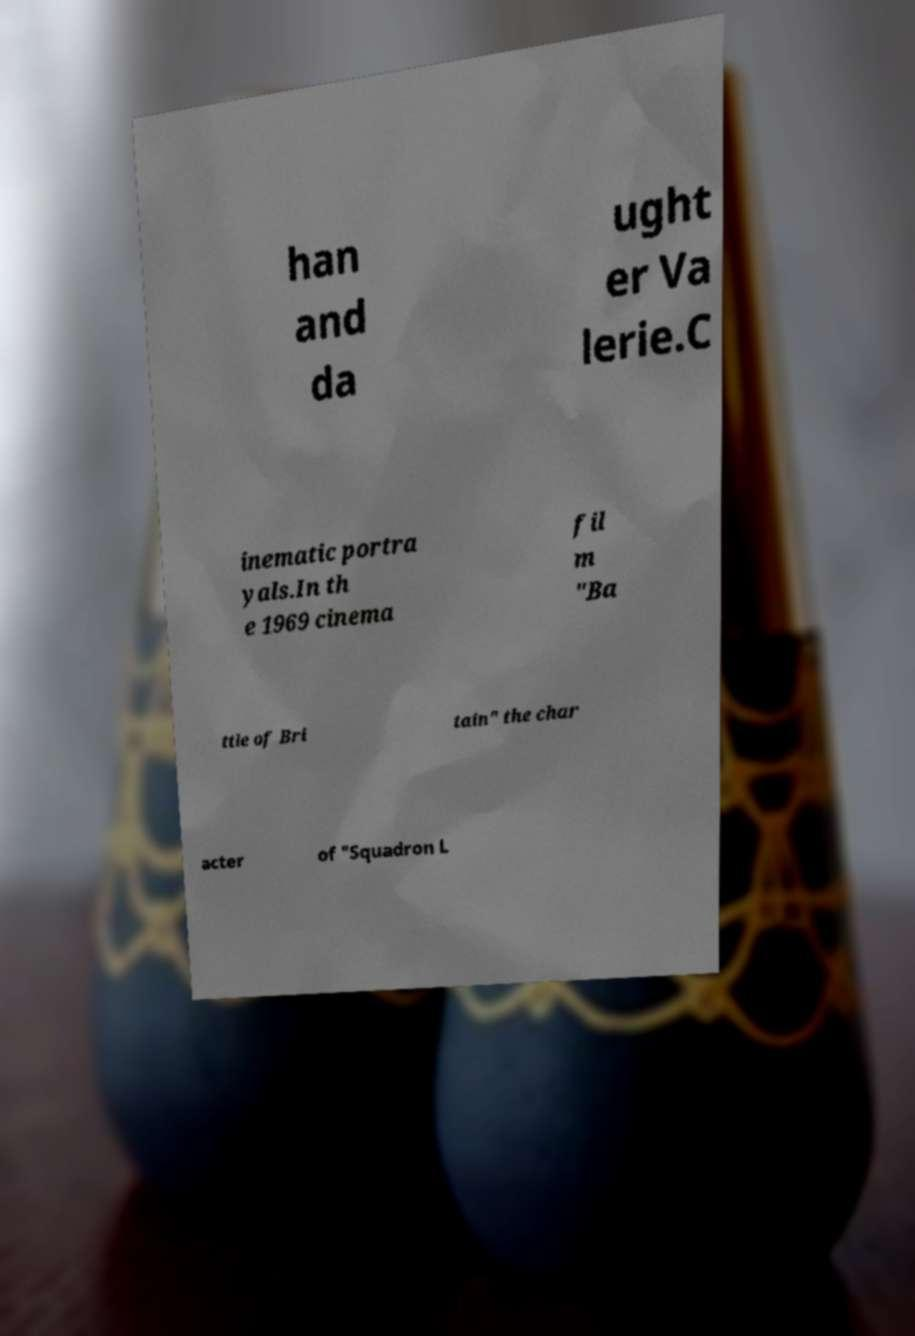There's text embedded in this image that I need extracted. Can you transcribe it verbatim? han and da ught er Va lerie.C inematic portra yals.In th e 1969 cinema fil m "Ba ttle of Bri tain" the char acter of "Squadron L 